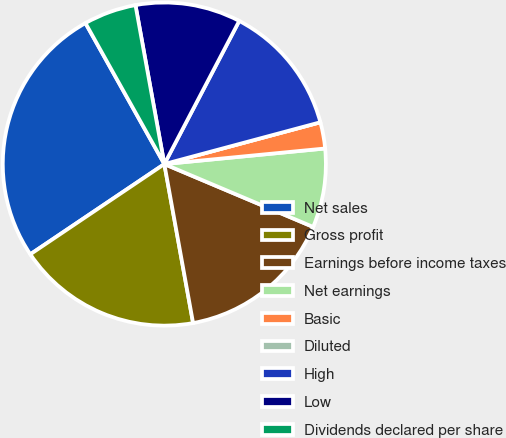<chart> <loc_0><loc_0><loc_500><loc_500><pie_chart><fcel>Net sales<fcel>Gross profit<fcel>Earnings before income taxes<fcel>Net earnings<fcel>Basic<fcel>Diluted<fcel>High<fcel>Low<fcel>Dividends declared per share<nl><fcel>26.31%<fcel>18.42%<fcel>15.79%<fcel>7.9%<fcel>2.63%<fcel>0.0%<fcel>13.16%<fcel>10.53%<fcel>5.26%<nl></chart> 